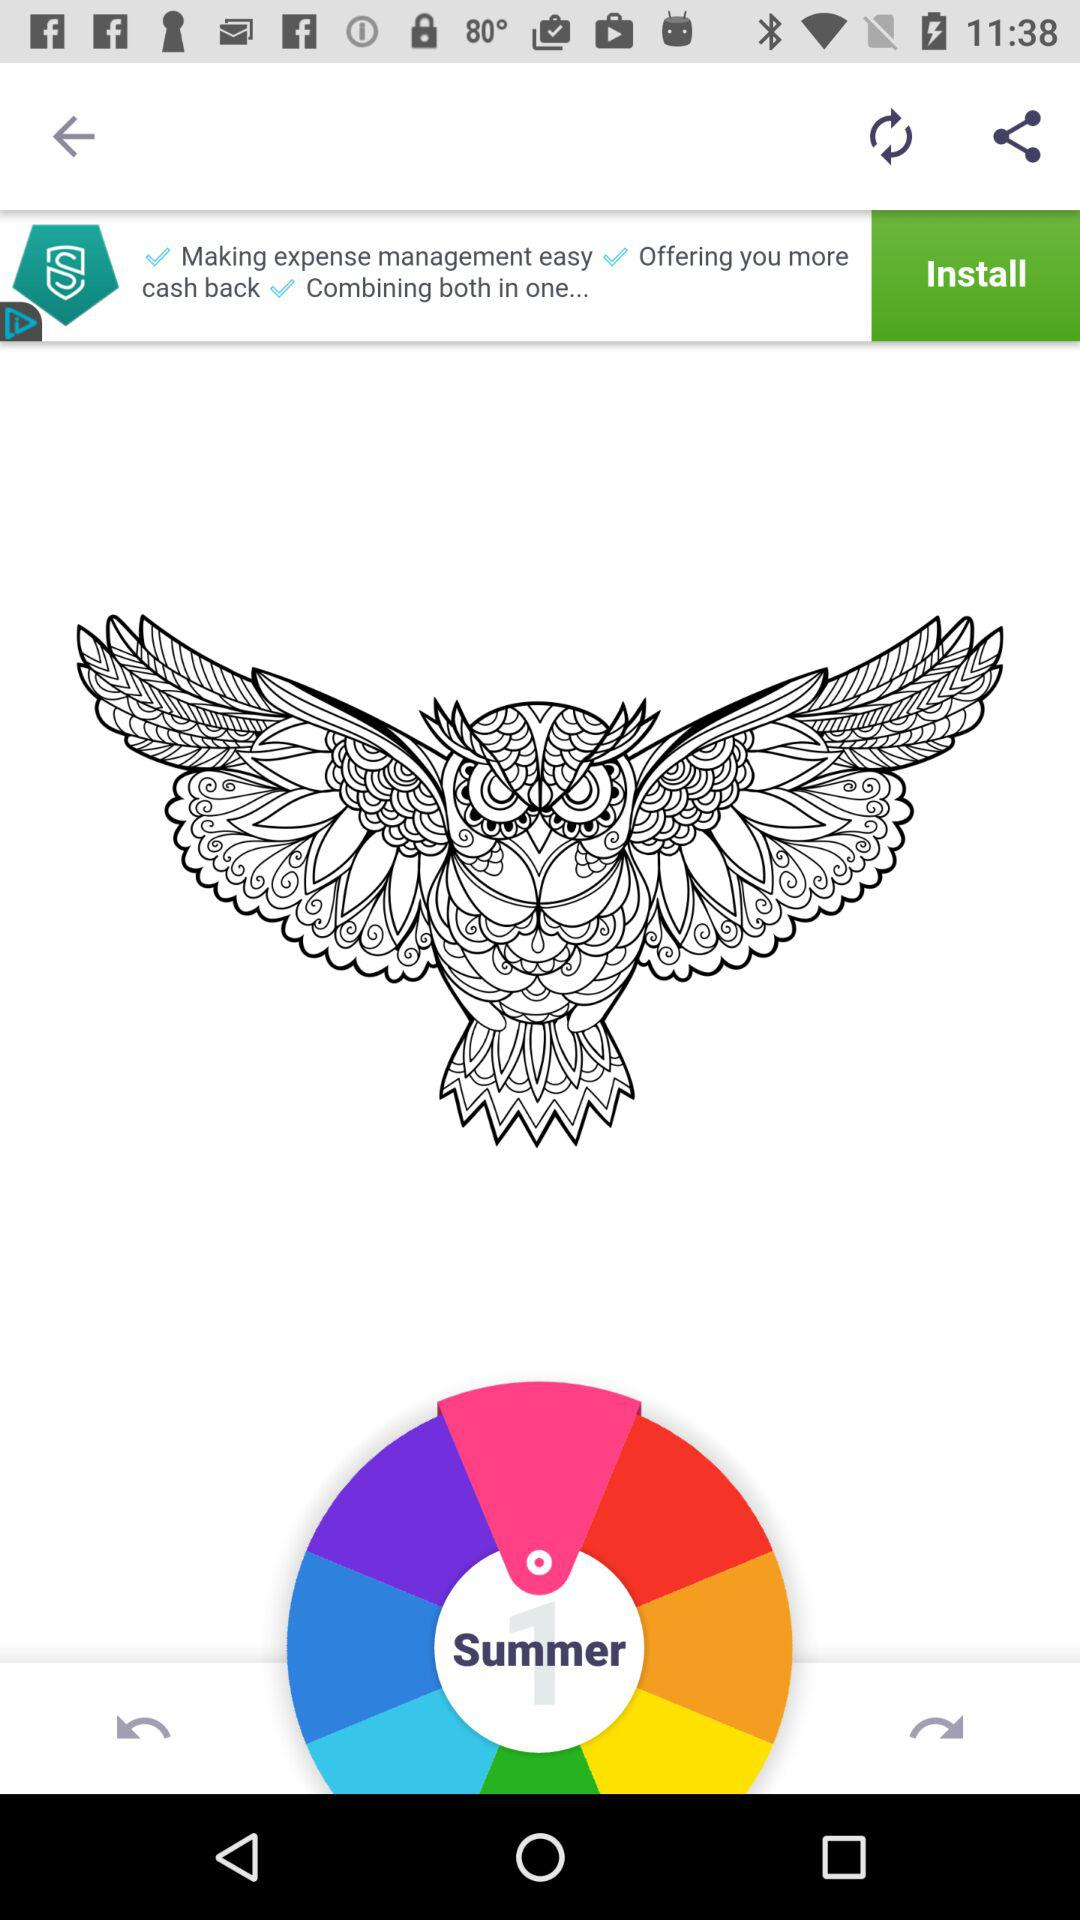How many circles are there on the screen?
Answer the question using a single word or phrase. 3 